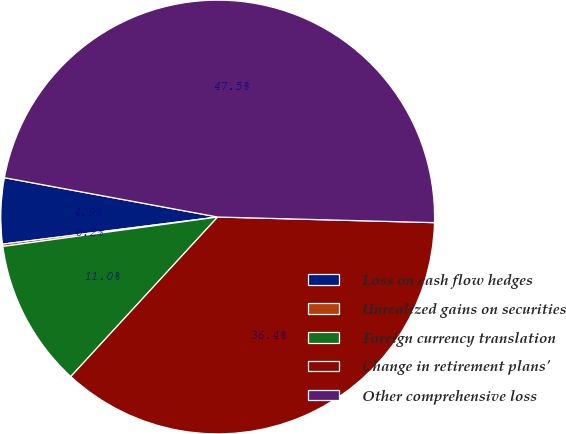<chart> <loc_0><loc_0><loc_500><loc_500><pie_chart><fcel>Loss on cash flow hedges<fcel>Unrealized gains on securities<fcel>Foreign currency translation<fcel>Change in retirement plans'<fcel>Other comprehensive loss<nl><fcel>4.9%<fcel>0.17%<fcel>10.99%<fcel>36.43%<fcel>47.51%<nl></chart> 